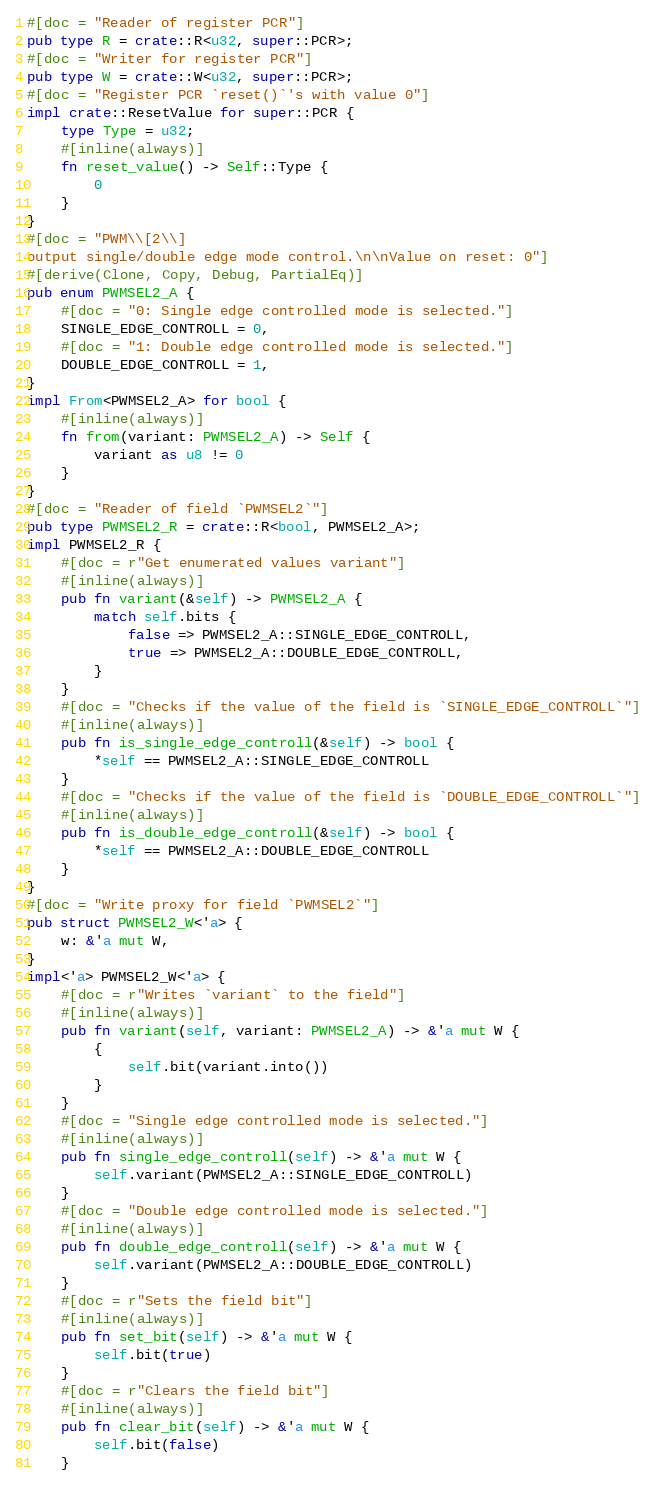<code> <loc_0><loc_0><loc_500><loc_500><_Rust_>#[doc = "Reader of register PCR"]
pub type R = crate::R<u32, super::PCR>;
#[doc = "Writer for register PCR"]
pub type W = crate::W<u32, super::PCR>;
#[doc = "Register PCR `reset()`'s with value 0"]
impl crate::ResetValue for super::PCR {
    type Type = u32;
    #[inline(always)]
    fn reset_value() -> Self::Type {
        0
    }
}
#[doc = "PWM\\[2\\]
output single/double edge mode control.\n\nValue on reset: 0"]
#[derive(Clone, Copy, Debug, PartialEq)]
pub enum PWMSEL2_A {
    #[doc = "0: Single edge controlled mode is selected."]
    SINGLE_EDGE_CONTROLL = 0,
    #[doc = "1: Double edge controlled mode is selected."]
    DOUBLE_EDGE_CONTROLL = 1,
}
impl From<PWMSEL2_A> for bool {
    #[inline(always)]
    fn from(variant: PWMSEL2_A) -> Self {
        variant as u8 != 0
    }
}
#[doc = "Reader of field `PWMSEL2`"]
pub type PWMSEL2_R = crate::R<bool, PWMSEL2_A>;
impl PWMSEL2_R {
    #[doc = r"Get enumerated values variant"]
    #[inline(always)]
    pub fn variant(&self) -> PWMSEL2_A {
        match self.bits {
            false => PWMSEL2_A::SINGLE_EDGE_CONTROLL,
            true => PWMSEL2_A::DOUBLE_EDGE_CONTROLL,
        }
    }
    #[doc = "Checks if the value of the field is `SINGLE_EDGE_CONTROLL`"]
    #[inline(always)]
    pub fn is_single_edge_controll(&self) -> bool {
        *self == PWMSEL2_A::SINGLE_EDGE_CONTROLL
    }
    #[doc = "Checks if the value of the field is `DOUBLE_EDGE_CONTROLL`"]
    #[inline(always)]
    pub fn is_double_edge_controll(&self) -> bool {
        *self == PWMSEL2_A::DOUBLE_EDGE_CONTROLL
    }
}
#[doc = "Write proxy for field `PWMSEL2`"]
pub struct PWMSEL2_W<'a> {
    w: &'a mut W,
}
impl<'a> PWMSEL2_W<'a> {
    #[doc = r"Writes `variant` to the field"]
    #[inline(always)]
    pub fn variant(self, variant: PWMSEL2_A) -> &'a mut W {
        {
            self.bit(variant.into())
        }
    }
    #[doc = "Single edge controlled mode is selected."]
    #[inline(always)]
    pub fn single_edge_controll(self) -> &'a mut W {
        self.variant(PWMSEL2_A::SINGLE_EDGE_CONTROLL)
    }
    #[doc = "Double edge controlled mode is selected."]
    #[inline(always)]
    pub fn double_edge_controll(self) -> &'a mut W {
        self.variant(PWMSEL2_A::DOUBLE_EDGE_CONTROLL)
    }
    #[doc = r"Sets the field bit"]
    #[inline(always)]
    pub fn set_bit(self) -> &'a mut W {
        self.bit(true)
    }
    #[doc = r"Clears the field bit"]
    #[inline(always)]
    pub fn clear_bit(self) -> &'a mut W {
        self.bit(false)
    }</code> 